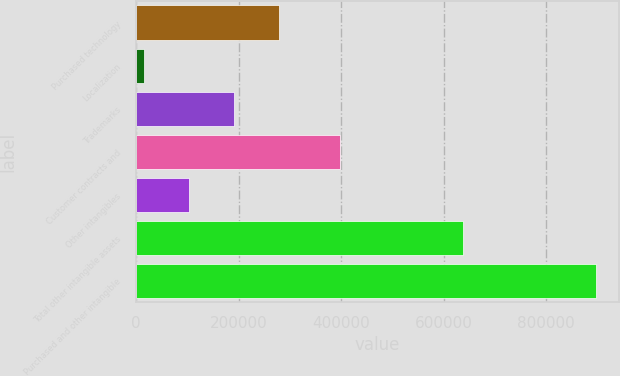Convert chart to OTSL. <chart><loc_0><loc_0><loc_500><loc_500><bar_chart><fcel>Purchased technology<fcel>Localization<fcel>Trademarks<fcel>Customer contracts and<fcel>Other intangibles<fcel>Total other intangible assets<fcel>Purchased and other intangible<nl><fcel>279339<fcel>14768<fcel>191149<fcel>398421<fcel>102958<fcel>636473<fcel>896671<nl></chart> 